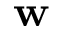<formula> <loc_0><loc_0><loc_500><loc_500>w</formula> 